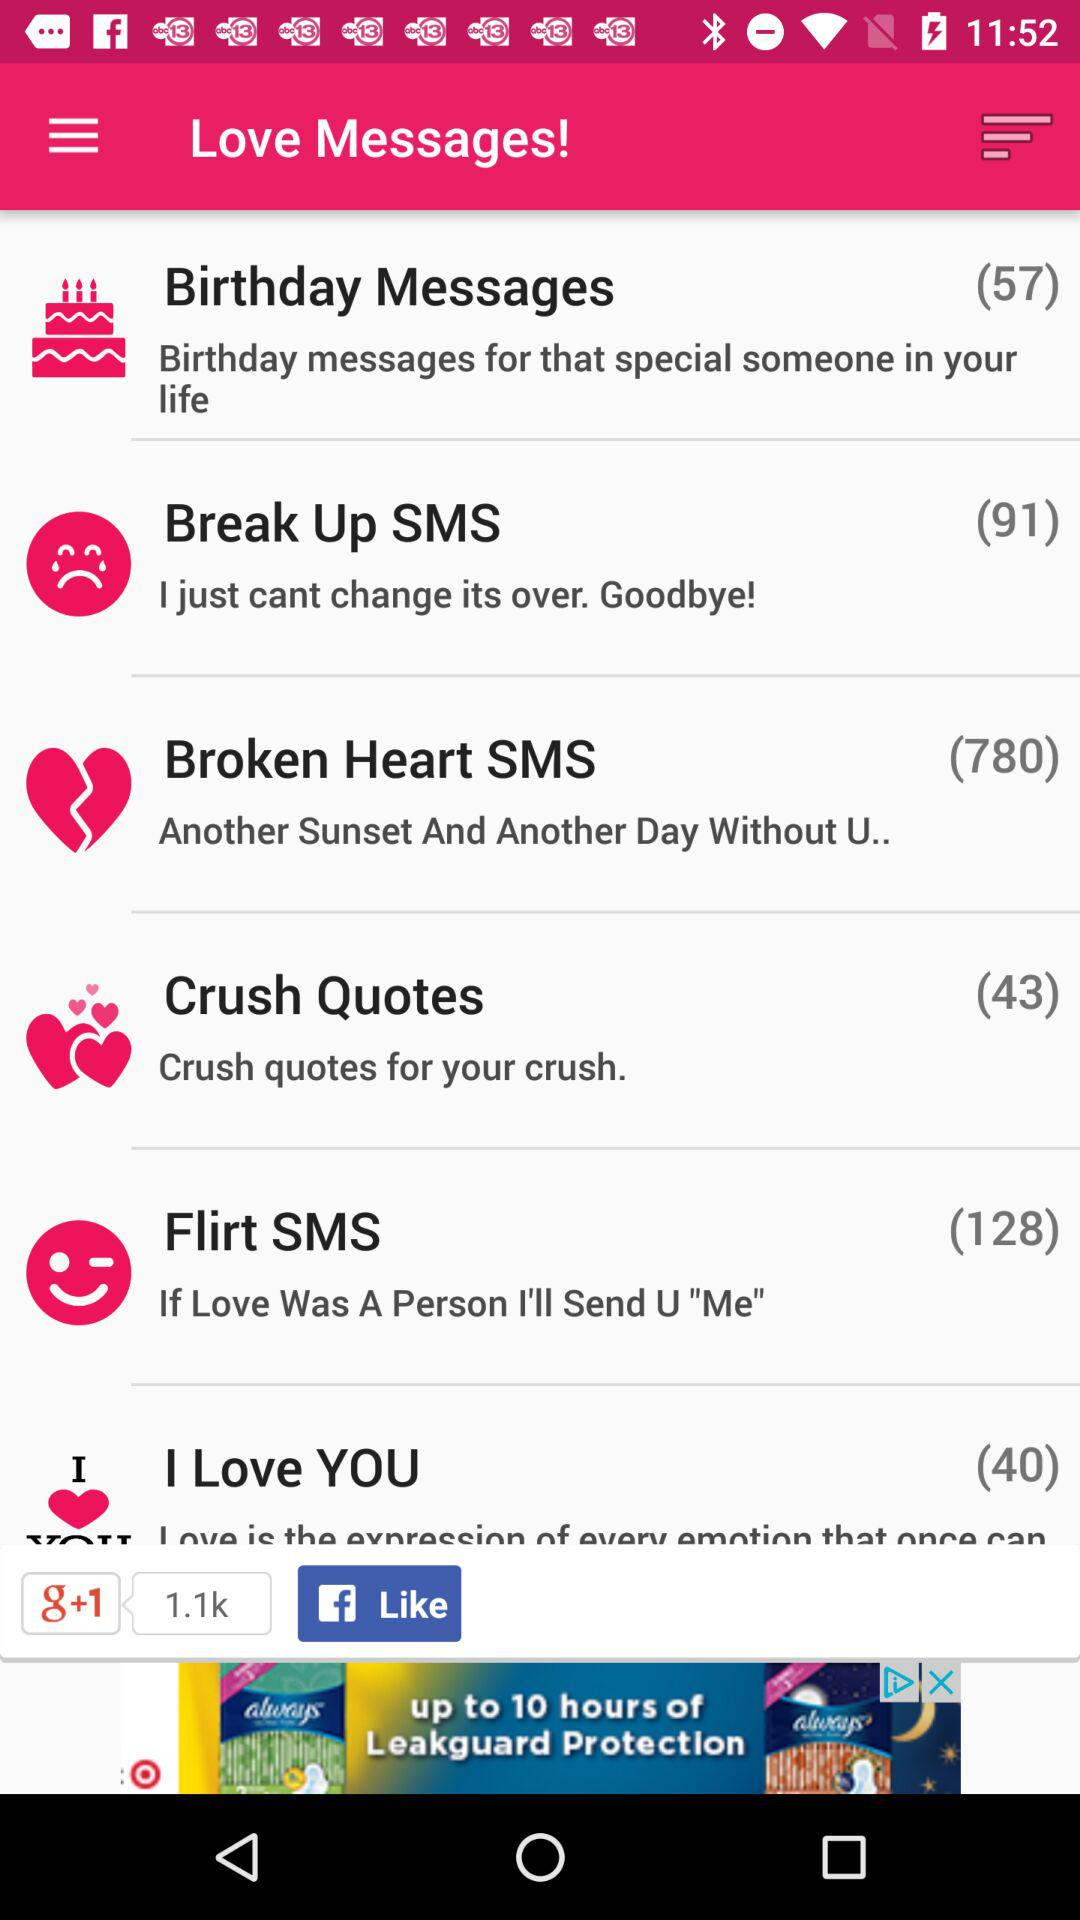How many messages are there in "Broken Heart SMS"? There are 780 messages in "Broken Heart SMS". 